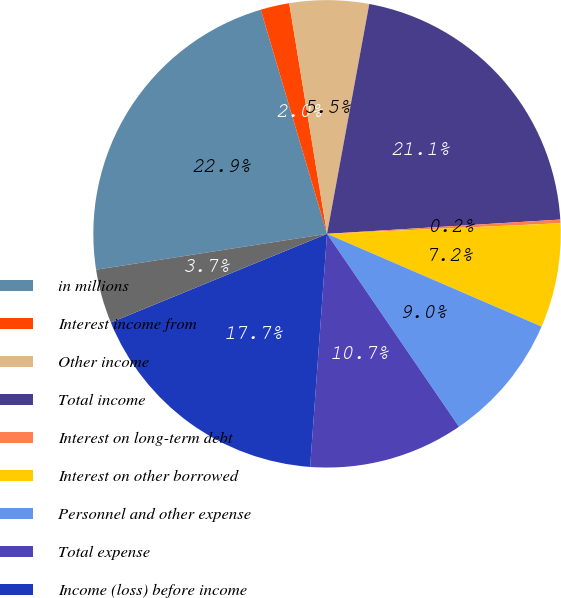Convert chart. <chart><loc_0><loc_0><loc_500><loc_500><pie_chart><fcel>in millions<fcel>Interest income from<fcel>Other income<fcel>Total income<fcel>Interest on long-term debt<fcel>Interest on other borrowed<fcel>Personnel and other expense<fcel>Total expense<fcel>Income (loss) before income<fcel>Income tax (expense) benefit<nl><fcel>22.88%<fcel>1.99%<fcel>5.48%<fcel>21.14%<fcel>0.25%<fcel>7.22%<fcel>8.96%<fcel>10.7%<fcel>17.66%<fcel>3.74%<nl></chart> 